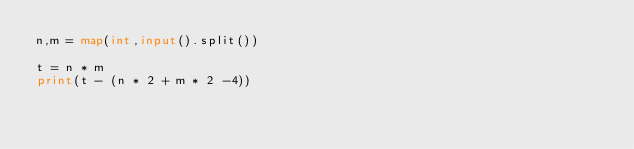Convert code to text. <code><loc_0><loc_0><loc_500><loc_500><_Python_>n,m = map(int,input().split())

t = n * m
print(t - (n * 2 + m * 2 -4))</code> 